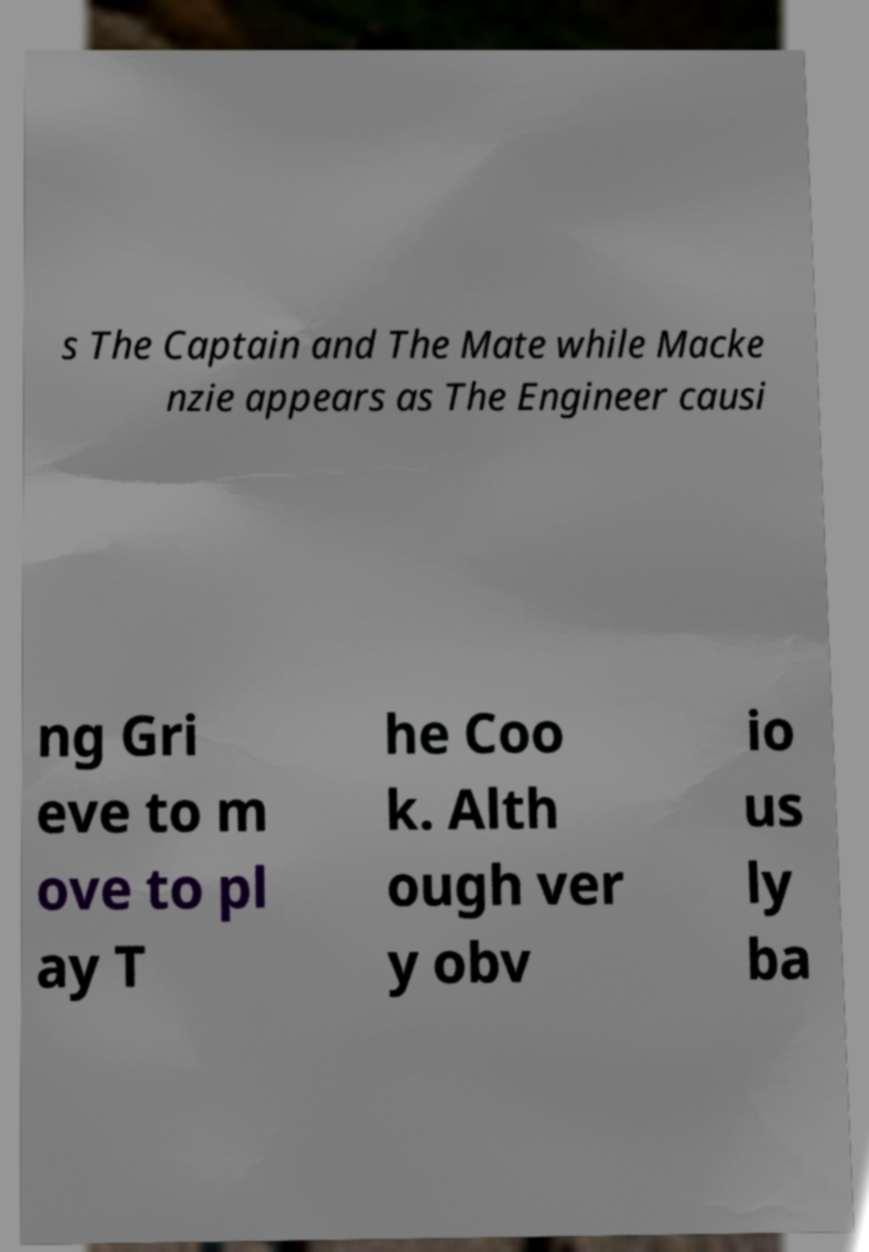Please read and relay the text visible in this image. What does it say? s The Captain and The Mate while Macke nzie appears as The Engineer causi ng Gri eve to m ove to pl ay T he Coo k. Alth ough ver y obv io us ly ba 